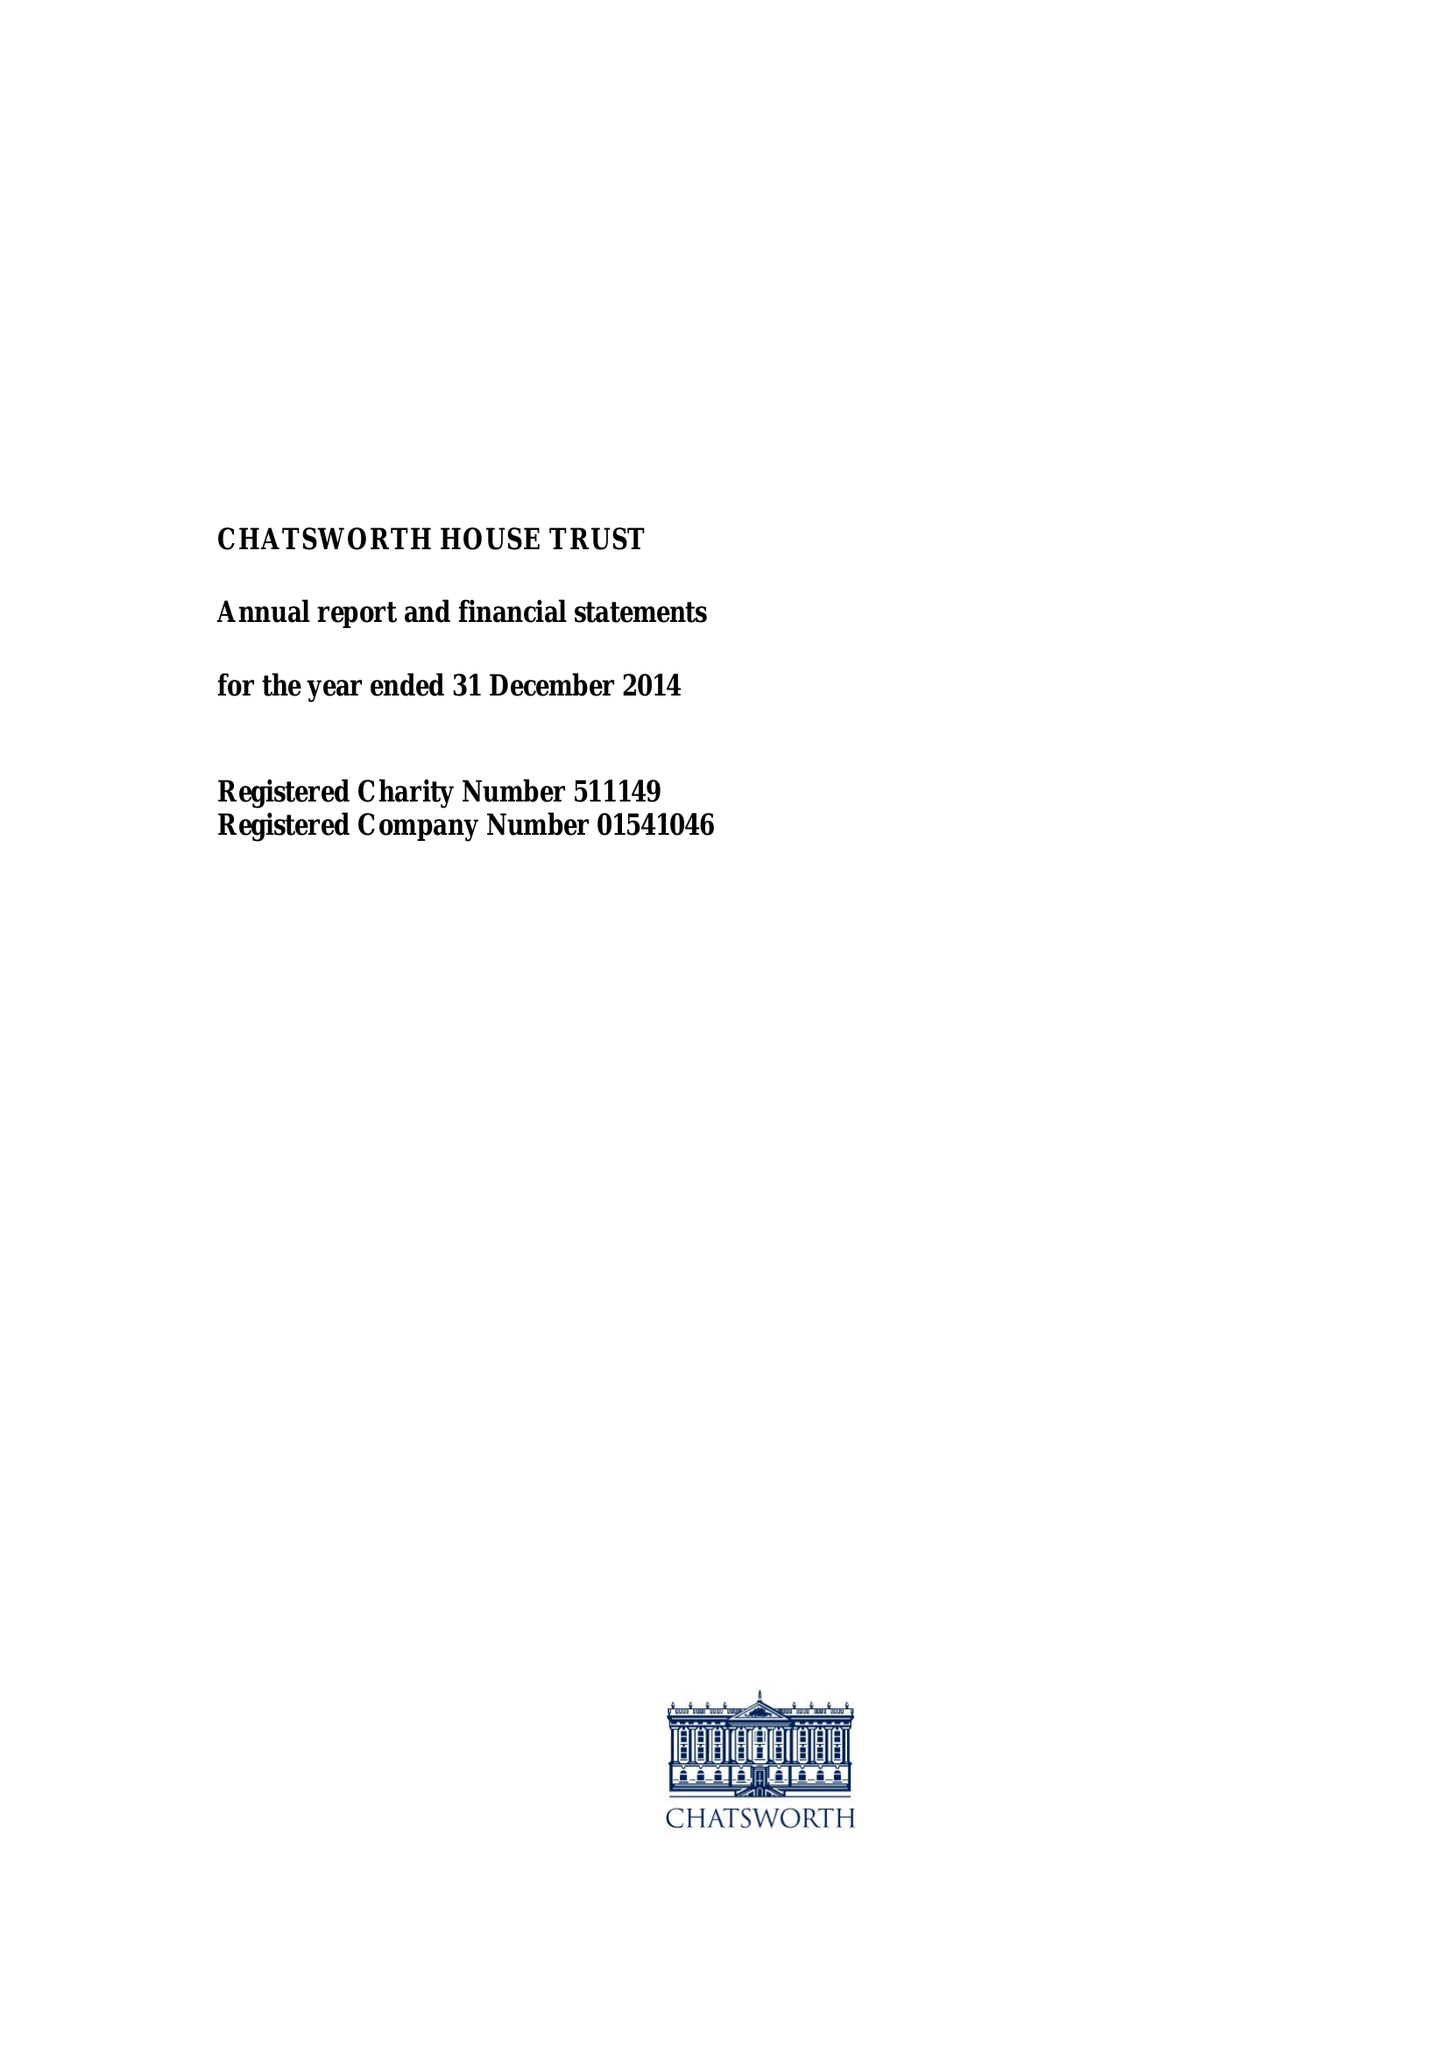What is the value for the spending_annually_in_british_pounds?
Answer the question using a single word or phrase. 10628278.00 